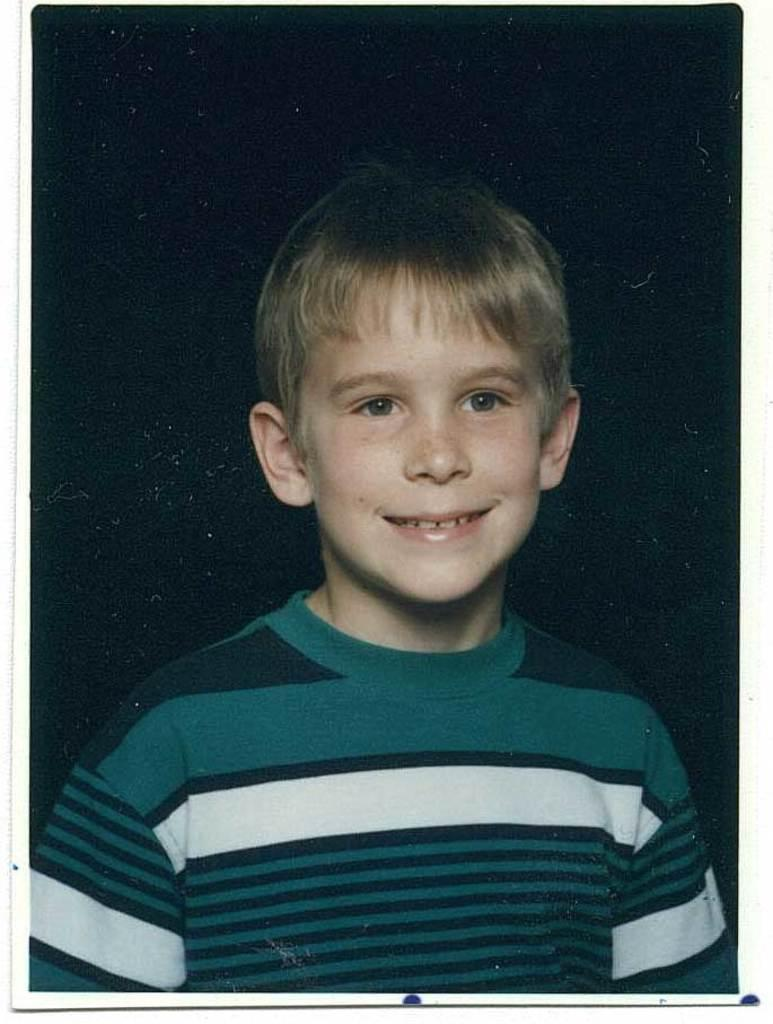What is the main subject of the image? The main subject of the image is a boy. What is the boy's facial expression in the image? The boy is smiling in the image. Can you describe the background of the image? The background of the image is dark. What type of oatmeal is the boy eating in the image? There is no oatmeal present in the image, and the boy is not eating anything. Can you hear the drum being played in the background of the image? There is no drum or any sound present in the image, as it is a still photograph. 